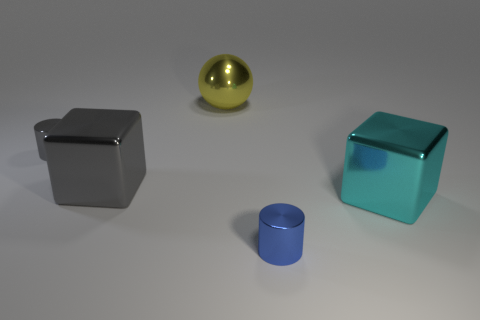Add 1 large yellow metal things. How many objects exist? 6 Subtract all cylinders. How many objects are left? 3 Add 4 cyan rubber things. How many cyan rubber things exist? 4 Subtract 0 red cylinders. How many objects are left? 5 Subtract all small red matte balls. Subtract all small gray metallic cylinders. How many objects are left? 4 Add 5 gray cylinders. How many gray cylinders are left? 6 